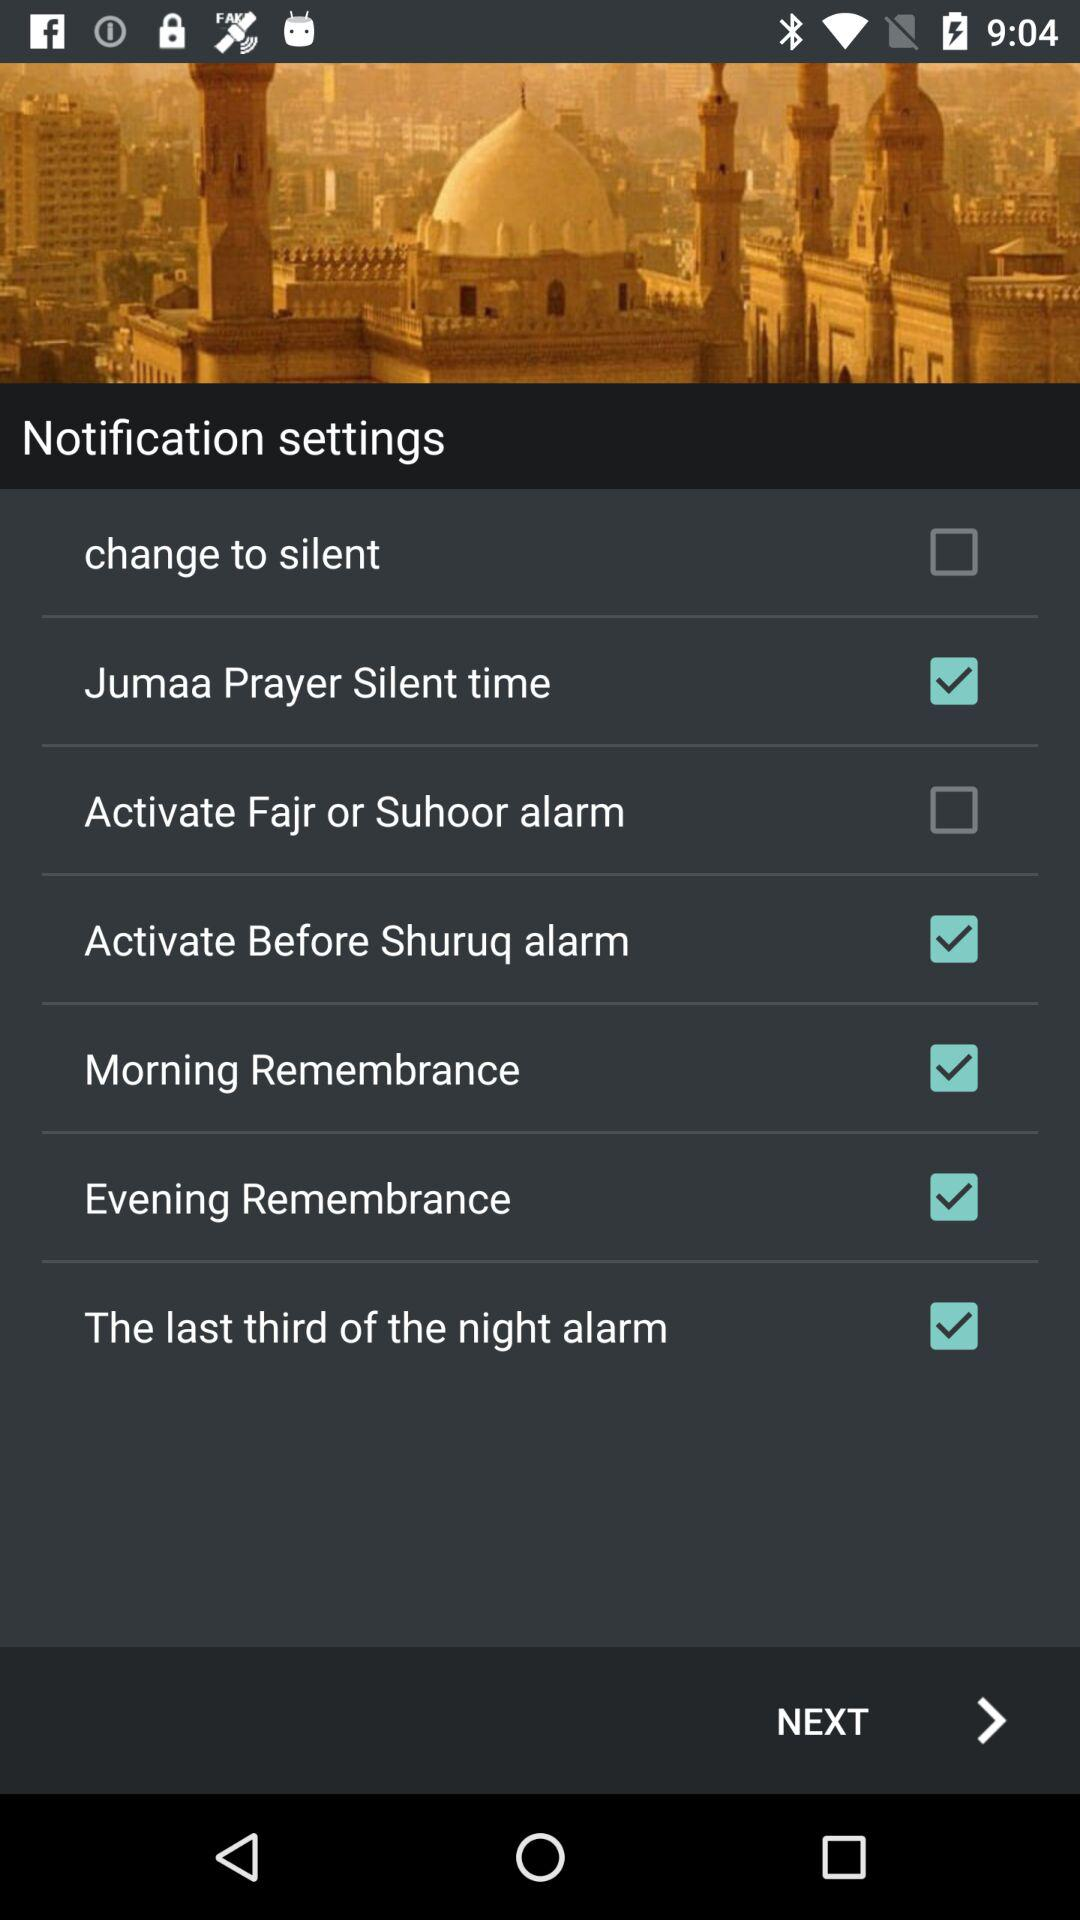What is the status of "Morning Remembrance"? The status of "Morning Remembrance" is "on". 